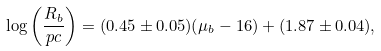Convert formula to latex. <formula><loc_0><loc_0><loc_500><loc_500>\log \left ( \frac { R _ { b } } { p c } \right ) = ( 0 . 4 5 \pm 0 . 0 5 ) ( \mu _ { b } - 1 6 ) + ( 1 . 8 7 \pm 0 . 0 4 ) ,</formula> 